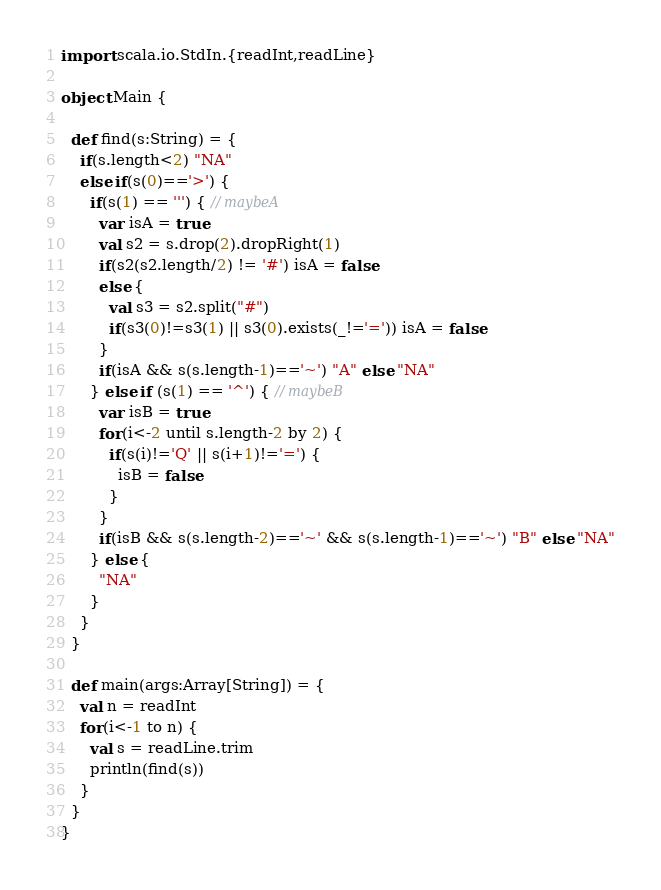Convert code to text. <code><loc_0><loc_0><loc_500><loc_500><_Scala_>import scala.io.StdIn.{readInt,readLine}

object Main {

  def find(s:String) = {
    if(s.length<2) "NA"
    else if(s(0)=='>') {
      if(s(1) == ''') { // maybeA
        var isA = true
        val s2 = s.drop(2).dropRight(1)
        if(s2(s2.length/2) != '#') isA = false
        else {
          val s3 = s2.split("#")
          if(s3(0)!=s3(1) || s3(0).exists(_!='=')) isA = false
        }
        if(isA && s(s.length-1)=='~') "A" else "NA"
      } else if (s(1) == '^') { // maybeB
        var isB = true
        for(i<-2 until s.length-2 by 2) {
          if(s(i)!='Q' || s(i+1)!='=') {
            isB = false
          }
        }
        if(isB && s(s.length-2)=='~' && s(s.length-1)=='~') "B" else "NA"
      } else {
        "NA"
      }
    }
  }

  def main(args:Array[String]) = {
    val n = readInt
    for(i<-1 to n) {
      val s = readLine.trim
      println(find(s))
    }
  }
}</code> 